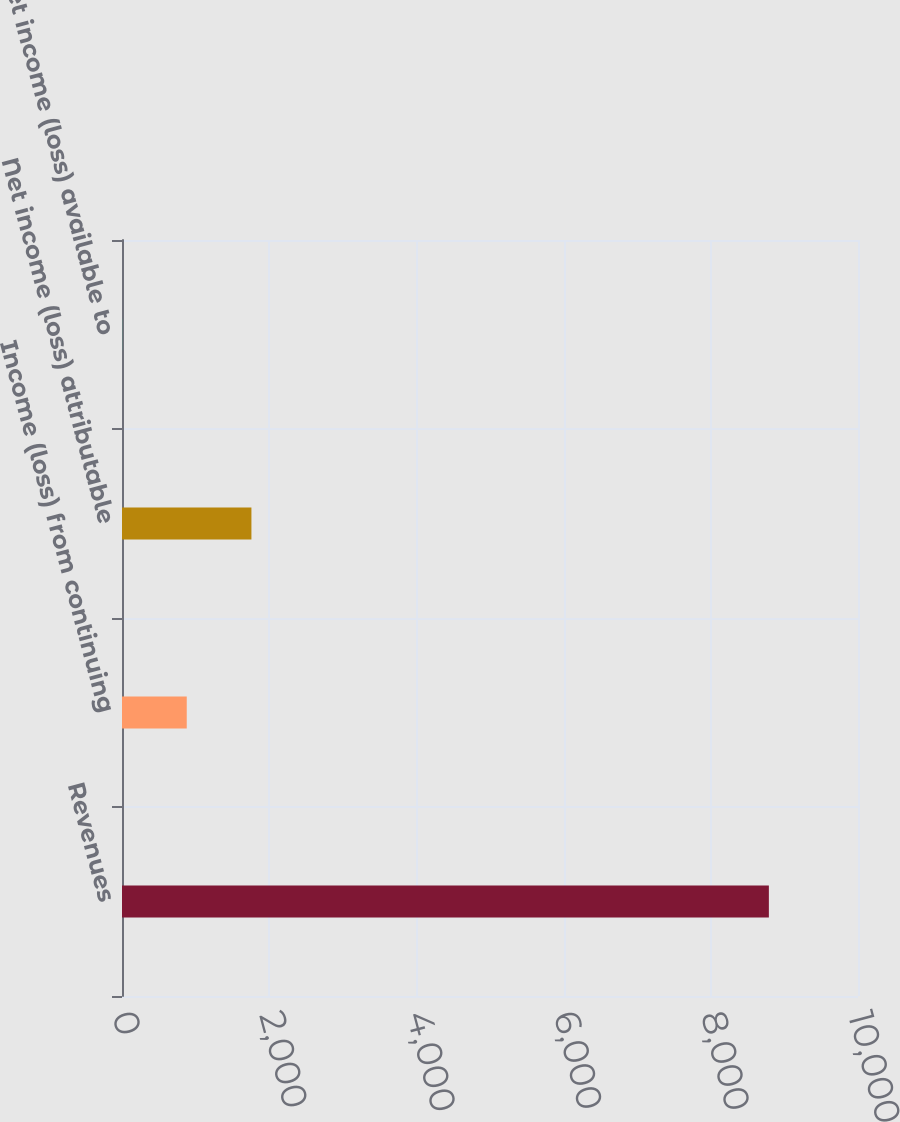Convert chart. <chart><loc_0><loc_0><loc_500><loc_500><bar_chart><fcel>Revenues<fcel>Income (loss) from continuing<fcel>Net income (loss) attributable<fcel>Net income (loss) available to<nl><fcel>8789<fcel>879.68<fcel>1758.49<fcel>0.87<nl></chart> 